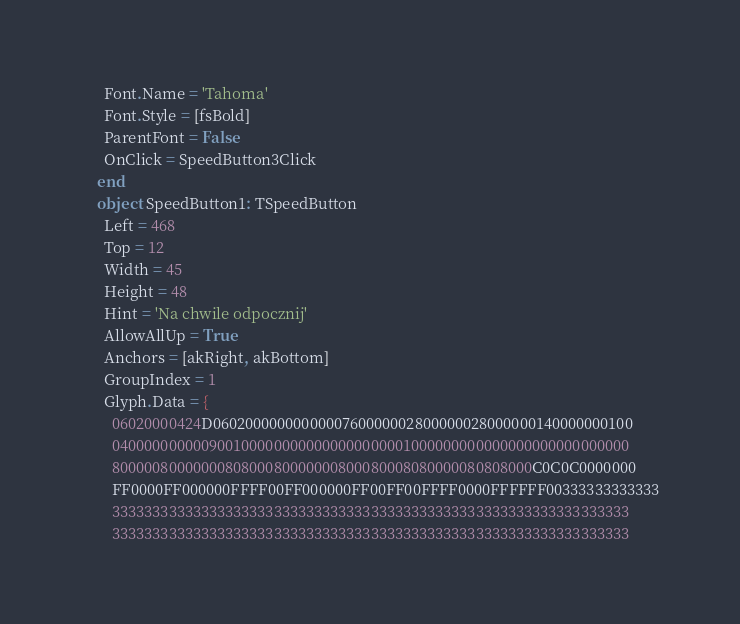<code> <loc_0><loc_0><loc_500><loc_500><_Pascal_>      Font.Name = 'Tahoma'
      Font.Style = [fsBold]
      ParentFont = False
      OnClick = SpeedButton3Click
    end
    object SpeedButton1: TSpeedButton
      Left = 468
      Top = 12
      Width = 45
      Height = 48
      Hint = 'Na chwile odpocznij'
      AllowAllUp = True
      Anchors = [akRight, akBottom]
      GroupIndex = 1
      Glyph.Data = {
        06020000424D0602000000000000760000002800000028000000140000000100
        0400000000009001000000000000000000001000000000000000000000000000
        8000008000000080800080000000800080008080000080808000C0C0C0000000
        FF0000FF000000FFFF00FF000000FF00FF00FFFF0000FFFFFF00333333333333
        3333333333333333333333333333333333333333333333333333333333333333
        3333333333333333333333333333333333333333333333333333333333333333</code> 